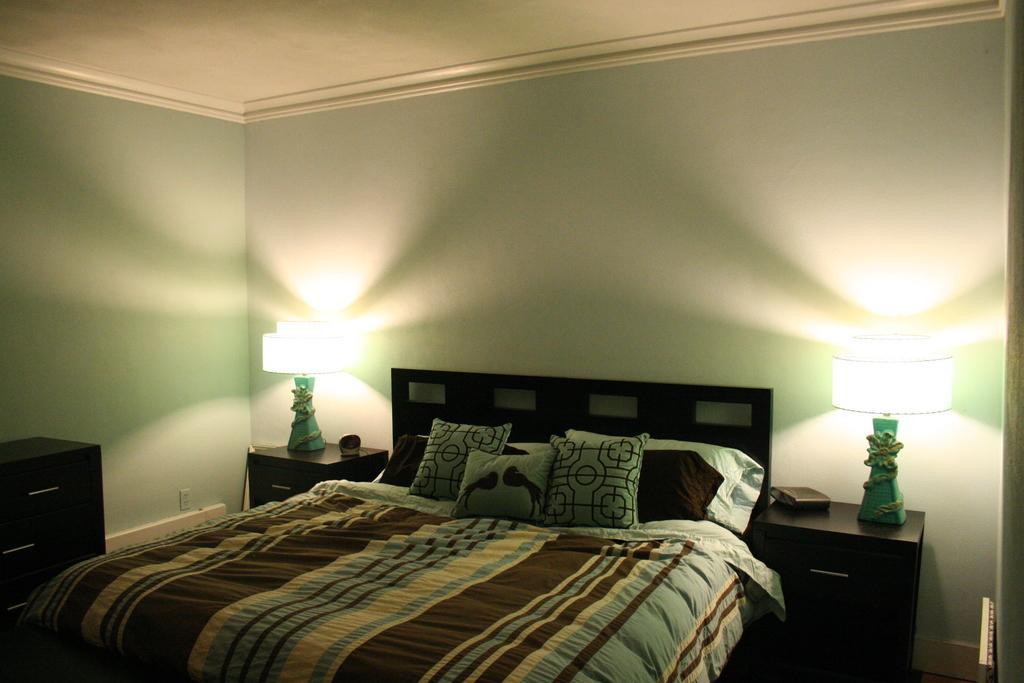Could you give a brief overview of what you see in this image? This is a room where a bed is in the center and two wooden tables are kept on the either side of the bed. These are two table lamps which are kept on the table. 